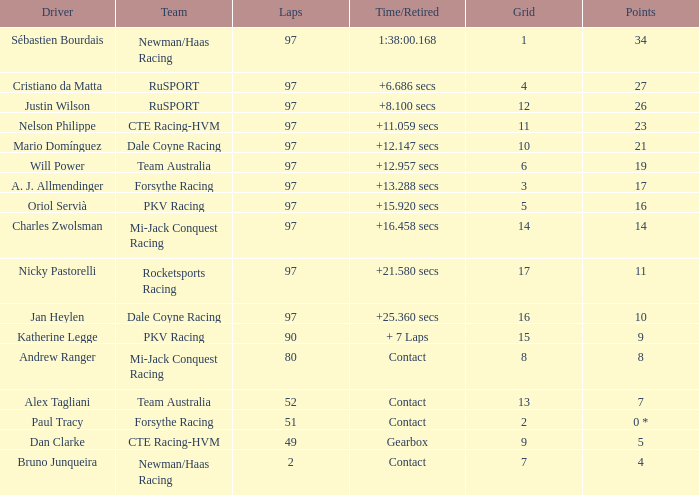Would you be able to parse every entry in this table? {'header': ['Driver', 'Team', 'Laps', 'Time/Retired', 'Grid', 'Points'], 'rows': [['Sébastien Bourdais', 'Newman/Haas Racing', '97', '1:38:00.168', '1', '34'], ['Cristiano da Matta', 'RuSPORT', '97', '+6.686 secs', '4', '27'], ['Justin Wilson', 'RuSPORT', '97', '+8.100 secs', '12', '26'], ['Nelson Philippe', 'CTE Racing-HVM', '97', '+11.059 secs', '11', '23'], ['Mario Domínguez', 'Dale Coyne Racing', '97', '+12.147 secs', '10', '21'], ['Will Power', 'Team Australia', '97', '+12.957 secs', '6', '19'], ['A. J. Allmendinger', 'Forsythe Racing', '97', '+13.288 secs', '3', '17'], ['Oriol Servià', 'PKV Racing', '97', '+15.920 secs', '5', '16'], ['Charles Zwolsman', 'Mi-Jack Conquest Racing', '97', '+16.458 secs', '14', '14'], ['Nicky Pastorelli', 'Rocketsports Racing', '97', '+21.580 secs', '17', '11'], ['Jan Heylen', 'Dale Coyne Racing', '97', '+25.360 secs', '16', '10'], ['Katherine Legge', 'PKV Racing', '90', '+ 7 Laps', '15', '9'], ['Andrew Ranger', 'Mi-Jack Conquest Racing', '80', 'Contact', '8', '8'], ['Alex Tagliani', 'Team Australia', '52', 'Contact', '13', '7'], ['Paul Tracy', 'Forsythe Racing', '51', 'Contact', '2', '0 *'], ['Dan Clarke', 'CTE Racing-HVM', '49', 'Gearbox', '9', '5'], ['Bruno Junqueira', 'Newman/Haas Racing', '2', 'Contact', '7', '4']]} What group does jan heylen compete with? Dale Coyne Racing. 